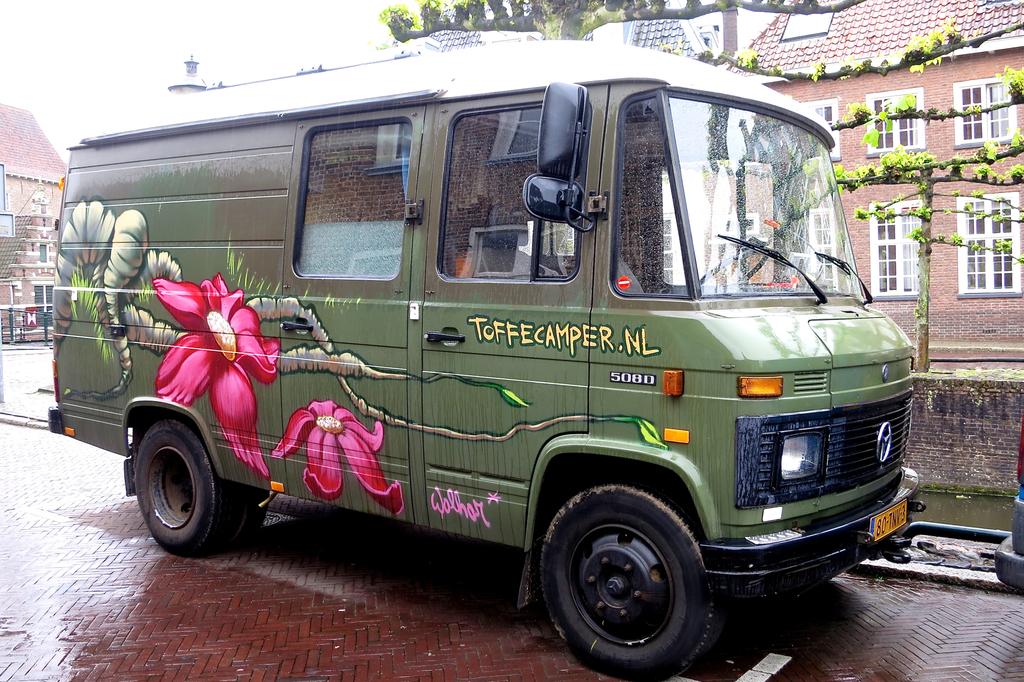What website is on the van?
Give a very brief answer. Toffecamper.nl. 